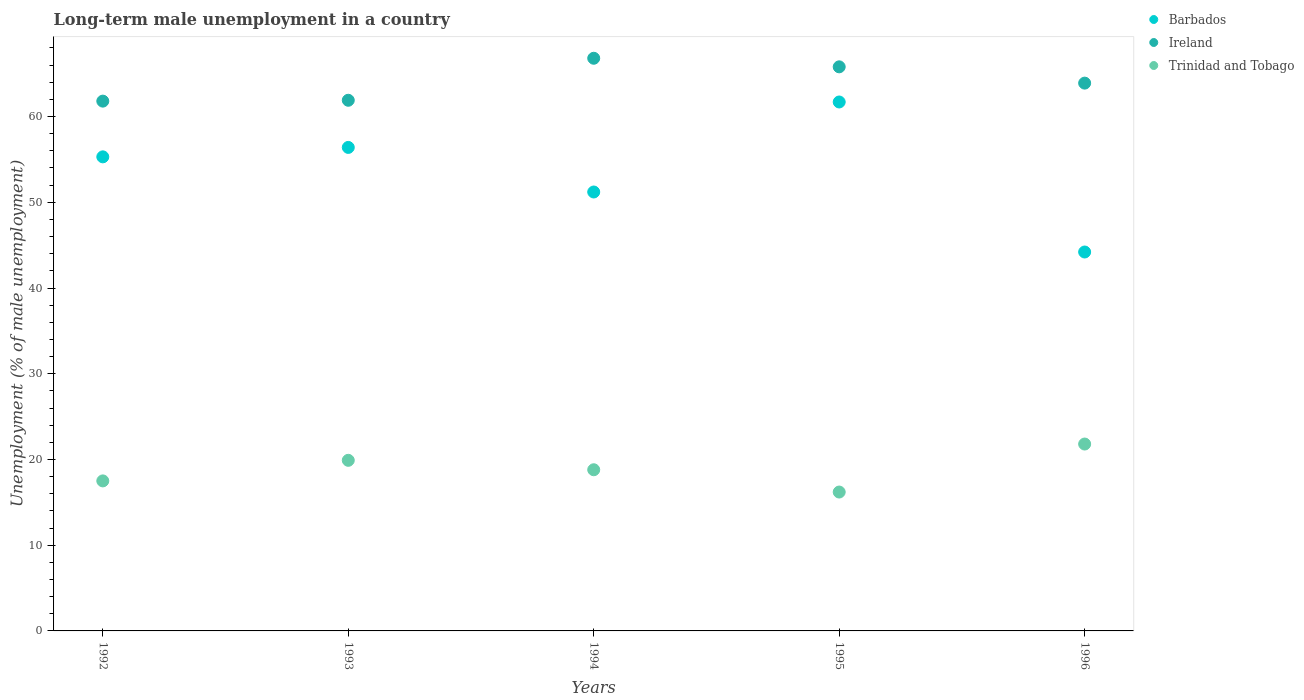Is the number of dotlines equal to the number of legend labels?
Provide a short and direct response. Yes. What is the percentage of long-term unemployed male population in Trinidad and Tobago in 1993?
Your answer should be very brief. 19.9. Across all years, what is the maximum percentage of long-term unemployed male population in Trinidad and Tobago?
Your response must be concise. 21.8. Across all years, what is the minimum percentage of long-term unemployed male population in Trinidad and Tobago?
Make the answer very short. 16.2. What is the total percentage of long-term unemployed male population in Ireland in the graph?
Your response must be concise. 320.2. What is the difference between the percentage of long-term unemployed male population in Barbados in 1993 and that in 1994?
Provide a short and direct response. 5.2. What is the difference between the percentage of long-term unemployed male population in Ireland in 1992 and the percentage of long-term unemployed male population in Trinidad and Tobago in 1994?
Give a very brief answer. 43. What is the average percentage of long-term unemployed male population in Trinidad and Tobago per year?
Your answer should be compact. 18.84. In the year 1992, what is the difference between the percentage of long-term unemployed male population in Trinidad and Tobago and percentage of long-term unemployed male population in Barbados?
Your answer should be compact. -37.8. In how many years, is the percentage of long-term unemployed male population in Barbados greater than 30 %?
Make the answer very short. 5. What is the ratio of the percentage of long-term unemployed male population in Trinidad and Tobago in 1993 to that in 1995?
Provide a succinct answer. 1.23. Is the percentage of long-term unemployed male population in Trinidad and Tobago in 1995 less than that in 1996?
Provide a short and direct response. Yes. What is the difference between the highest and the second highest percentage of long-term unemployed male population in Ireland?
Your response must be concise. 1. What is the difference between the highest and the lowest percentage of long-term unemployed male population in Trinidad and Tobago?
Provide a short and direct response. 5.6. In how many years, is the percentage of long-term unemployed male population in Barbados greater than the average percentage of long-term unemployed male population in Barbados taken over all years?
Offer a very short reply. 3. Is the sum of the percentage of long-term unemployed male population in Barbados in 1992 and 1995 greater than the maximum percentage of long-term unemployed male population in Ireland across all years?
Offer a very short reply. Yes. Is it the case that in every year, the sum of the percentage of long-term unemployed male population in Barbados and percentage of long-term unemployed male population in Trinidad and Tobago  is greater than the percentage of long-term unemployed male population in Ireland?
Offer a terse response. Yes. Are the values on the major ticks of Y-axis written in scientific E-notation?
Provide a short and direct response. No. Does the graph contain grids?
Ensure brevity in your answer.  No. Where does the legend appear in the graph?
Keep it short and to the point. Top right. How many legend labels are there?
Provide a short and direct response. 3. How are the legend labels stacked?
Your answer should be very brief. Vertical. What is the title of the graph?
Your response must be concise. Long-term male unemployment in a country. Does "St. Vincent and the Grenadines" appear as one of the legend labels in the graph?
Provide a short and direct response. No. What is the label or title of the Y-axis?
Provide a succinct answer. Unemployment (% of male unemployment). What is the Unemployment (% of male unemployment) of Barbados in 1992?
Your response must be concise. 55.3. What is the Unemployment (% of male unemployment) in Ireland in 1992?
Make the answer very short. 61.8. What is the Unemployment (% of male unemployment) of Trinidad and Tobago in 1992?
Make the answer very short. 17.5. What is the Unemployment (% of male unemployment) in Barbados in 1993?
Your answer should be very brief. 56.4. What is the Unemployment (% of male unemployment) of Ireland in 1993?
Offer a very short reply. 61.9. What is the Unemployment (% of male unemployment) of Trinidad and Tobago in 1993?
Make the answer very short. 19.9. What is the Unemployment (% of male unemployment) of Barbados in 1994?
Ensure brevity in your answer.  51.2. What is the Unemployment (% of male unemployment) of Ireland in 1994?
Ensure brevity in your answer.  66.8. What is the Unemployment (% of male unemployment) in Trinidad and Tobago in 1994?
Your answer should be compact. 18.8. What is the Unemployment (% of male unemployment) in Barbados in 1995?
Make the answer very short. 61.7. What is the Unemployment (% of male unemployment) of Ireland in 1995?
Provide a succinct answer. 65.8. What is the Unemployment (% of male unemployment) of Trinidad and Tobago in 1995?
Provide a short and direct response. 16.2. What is the Unemployment (% of male unemployment) in Barbados in 1996?
Your answer should be very brief. 44.2. What is the Unemployment (% of male unemployment) in Ireland in 1996?
Make the answer very short. 63.9. What is the Unemployment (% of male unemployment) of Trinidad and Tobago in 1996?
Provide a short and direct response. 21.8. Across all years, what is the maximum Unemployment (% of male unemployment) in Barbados?
Offer a terse response. 61.7. Across all years, what is the maximum Unemployment (% of male unemployment) of Ireland?
Your response must be concise. 66.8. Across all years, what is the maximum Unemployment (% of male unemployment) in Trinidad and Tobago?
Provide a short and direct response. 21.8. Across all years, what is the minimum Unemployment (% of male unemployment) in Barbados?
Provide a short and direct response. 44.2. Across all years, what is the minimum Unemployment (% of male unemployment) of Ireland?
Your response must be concise. 61.8. Across all years, what is the minimum Unemployment (% of male unemployment) of Trinidad and Tobago?
Ensure brevity in your answer.  16.2. What is the total Unemployment (% of male unemployment) of Barbados in the graph?
Your answer should be compact. 268.8. What is the total Unemployment (% of male unemployment) in Ireland in the graph?
Ensure brevity in your answer.  320.2. What is the total Unemployment (% of male unemployment) in Trinidad and Tobago in the graph?
Provide a short and direct response. 94.2. What is the difference between the Unemployment (% of male unemployment) of Barbados in 1992 and that in 1993?
Ensure brevity in your answer.  -1.1. What is the difference between the Unemployment (% of male unemployment) in Ireland in 1992 and that in 1993?
Your answer should be compact. -0.1. What is the difference between the Unemployment (% of male unemployment) of Trinidad and Tobago in 1992 and that in 1993?
Your response must be concise. -2.4. What is the difference between the Unemployment (% of male unemployment) in Barbados in 1992 and that in 1995?
Provide a short and direct response. -6.4. What is the difference between the Unemployment (% of male unemployment) of Ireland in 1992 and that in 1995?
Offer a terse response. -4. What is the difference between the Unemployment (% of male unemployment) in Ireland in 1992 and that in 1996?
Ensure brevity in your answer.  -2.1. What is the difference between the Unemployment (% of male unemployment) in Trinidad and Tobago in 1992 and that in 1996?
Your response must be concise. -4.3. What is the difference between the Unemployment (% of male unemployment) in Ireland in 1993 and that in 1994?
Your response must be concise. -4.9. What is the difference between the Unemployment (% of male unemployment) in Trinidad and Tobago in 1993 and that in 1994?
Offer a very short reply. 1.1. What is the difference between the Unemployment (% of male unemployment) in Barbados in 1993 and that in 1995?
Offer a very short reply. -5.3. What is the difference between the Unemployment (% of male unemployment) of Trinidad and Tobago in 1993 and that in 1995?
Ensure brevity in your answer.  3.7. What is the difference between the Unemployment (% of male unemployment) in Trinidad and Tobago in 1993 and that in 1996?
Make the answer very short. -1.9. What is the difference between the Unemployment (% of male unemployment) of Barbados in 1994 and that in 1995?
Provide a short and direct response. -10.5. What is the difference between the Unemployment (% of male unemployment) of Ireland in 1994 and that in 1995?
Ensure brevity in your answer.  1. What is the difference between the Unemployment (% of male unemployment) in Trinidad and Tobago in 1994 and that in 1995?
Your response must be concise. 2.6. What is the difference between the Unemployment (% of male unemployment) of Barbados in 1994 and that in 1996?
Provide a succinct answer. 7. What is the difference between the Unemployment (% of male unemployment) in Barbados in 1995 and that in 1996?
Offer a terse response. 17.5. What is the difference between the Unemployment (% of male unemployment) of Trinidad and Tobago in 1995 and that in 1996?
Provide a succinct answer. -5.6. What is the difference between the Unemployment (% of male unemployment) in Barbados in 1992 and the Unemployment (% of male unemployment) in Trinidad and Tobago in 1993?
Offer a very short reply. 35.4. What is the difference between the Unemployment (% of male unemployment) of Ireland in 1992 and the Unemployment (% of male unemployment) of Trinidad and Tobago in 1993?
Ensure brevity in your answer.  41.9. What is the difference between the Unemployment (% of male unemployment) of Barbados in 1992 and the Unemployment (% of male unemployment) of Trinidad and Tobago in 1994?
Your answer should be very brief. 36.5. What is the difference between the Unemployment (% of male unemployment) of Ireland in 1992 and the Unemployment (% of male unemployment) of Trinidad and Tobago in 1994?
Offer a very short reply. 43. What is the difference between the Unemployment (% of male unemployment) in Barbados in 1992 and the Unemployment (% of male unemployment) in Ireland in 1995?
Provide a succinct answer. -10.5. What is the difference between the Unemployment (% of male unemployment) in Barbados in 1992 and the Unemployment (% of male unemployment) in Trinidad and Tobago in 1995?
Keep it short and to the point. 39.1. What is the difference between the Unemployment (% of male unemployment) of Ireland in 1992 and the Unemployment (% of male unemployment) of Trinidad and Tobago in 1995?
Provide a short and direct response. 45.6. What is the difference between the Unemployment (% of male unemployment) of Barbados in 1992 and the Unemployment (% of male unemployment) of Trinidad and Tobago in 1996?
Give a very brief answer. 33.5. What is the difference between the Unemployment (% of male unemployment) in Barbados in 1993 and the Unemployment (% of male unemployment) in Trinidad and Tobago in 1994?
Your response must be concise. 37.6. What is the difference between the Unemployment (% of male unemployment) of Ireland in 1993 and the Unemployment (% of male unemployment) of Trinidad and Tobago in 1994?
Offer a terse response. 43.1. What is the difference between the Unemployment (% of male unemployment) of Barbados in 1993 and the Unemployment (% of male unemployment) of Trinidad and Tobago in 1995?
Make the answer very short. 40.2. What is the difference between the Unemployment (% of male unemployment) in Ireland in 1993 and the Unemployment (% of male unemployment) in Trinidad and Tobago in 1995?
Give a very brief answer. 45.7. What is the difference between the Unemployment (% of male unemployment) of Barbados in 1993 and the Unemployment (% of male unemployment) of Trinidad and Tobago in 1996?
Provide a short and direct response. 34.6. What is the difference between the Unemployment (% of male unemployment) of Ireland in 1993 and the Unemployment (% of male unemployment) of Trinidad and Tobago in 1996?
Offer a terse response. 40.1. What is the difference between the Unemployment (% of male unemployment) in Barbados in 1994 and the Unemployment (% of male unemployment) in Ireland in 1995?
Your answer should be compact. -14.6. What is the difference between the Unemployment (% of male unemployment) of Barbados in 1994 and the Unemployment (% of male unemployment) of Trinidad and Tobago in 1995?
Give a very brief answer. 35. What is the difference between the Unemployment (% of male unemployment) in Ireland in 1994 and the Unemployment (% of male unemployment) in Trinidad and Tobago in 1995?
Ensure brevity in your answer.  50.6. What is the difference between the Unemployment (% of male unemployment) of Barbados in 1994 and the Unemployment (% of male unemployment) of Trinidad and Tobago in 1996?
Keep it short and to the point. 29.4. What is the difference between the Unemployment (% of male unemployment) of Ireland in 1994 and the Unemployment (% of male unemployment) of Trinidad and Tobago in 1996?
Your answer should be compact. 45. What is the difference between the Unemployment (% of male unemployment) in Barbados in 1995 and the Unemployment (% of male unemployment) in Ireland in 1996?
Offer a terse response. -2.2. What is the difference between the Unemployment (% of male unemployment) in Barbados in 1995 and the Unemployment (% of male unemployment) in Trinidad and Tobago in 1996?
Offer a very short reply. 39.9. What is the difference between the Unemployment (% of male unemployment) of Ireland in 1995 and the Unemployment (% of male unemployment) of Trinidad and Tobago in 1996?
Ensure brevity in your answer.  44. What is the average Unemployment (% of male unemployment) in Barbados per year?
Ensure brevity in your answer.  53.76. What is the average Unemployment (% of male unemployment) of Ireland per year?
Make the answer very short. 64.04. What is the average Unemployment (% of male unemployment) in Trinidad and Tobago per year?
Provide a succinct answer. 18.84. In the year 1992, what is the difference between the Unemployment (% of male unemployment) of Barbados and Unemployment (% of male unemployment) of Ireland?
Offer a very short reply. -6.5. In the year 1992, what is the difference between the Unemployment (% of male unemployment) in Barbados and Unemployment (% of male unemployment) in Trinidad and Tobago?
Make the answer very short. 37.8. In the year 1992, what is the difference between the Unemployment (% of male unemployment) in Ireland and Unemployment (% of male unemployment) in Trinidad and Tobago?
Your response must be concise. 44.3. In the year 1993, what is the difference between the Unemployment (% of male unemployment) of Barbados and Unemployment (% of male unemployment) of Ireland?
Provide a short and direct response. -5.5. In the year 1993, what is the difference between the Unemployment (% of male unemployment) of Barbados and Unemployment (% of male unemployment) of Trinidad and Tobago?
Your answer should be compact. 36.5. In the year 1993, what is the difference between the Unemployment (% of male unemployment) of Ireland and Unemployment (% of male unemployment) of Trinidad and Tobago?
Provide a succinct answer. 42. In the year 1994, what is the difference between the Unemployment (% of male unemployment) of Barbados and Unemployment (% of male unemployment) of Ireland?
Your response must be concise. -15.6. In the year 1994, what is the difference between the Unemployment (% of male unemployment) of Barbados and Unemployment (% of male unemployment) of Trinidad and Tobago?
Provide a short and direct response. 32.4. In the year 1994, what is the difference between the Unemployment (% of male unemployment) in Ireland and Unemployment (% of male unemployment) in Trinidad and Tobago?
Your answer should be very brief. 48. In the year 1995, what is the difference between the Unemployment (% of male unemployment) in Barbados and Unemployment (% of male unemployment) in Trinidad and Tobago?
Provide a succinct answer. 45.5. In the year 1995, what is the difference between the Unemployment (% of male unemployment) of Ireland and Unemployment (% of male unemployment) of Trinidad and Tobago?
Give a very brief answer. 49.6. In the year 1996, what is the difference between the Unemployment (% of male unemployment) in Barbados and Unemployment (% of male unemployment) in Ireland?
Ensure brevity in your answer.  -19.7. In the year 1996, what is the difference between the Unemployment (% of male unemployment) of Barbados and Unemployment (% of male unemployment) of Trinidad and Tobago?
Provide a short and direct response. 22.4. In the year 1996, what is the difference between the Unemployment (% of male unemployment) of Ireland and Unemployment (% of male unemployment) of Trinidad and Tobago?
Your answer should be very brief. 42.1. What is the ratio of the Unemployment (% of male unemployment) in Barbados in 1992 to that in 1993?
Ensure brevity in your answer.  0.98. What is the ratio of the Unemployment (% of male unemployment) in Ireland in 1992 to that in 1993?
Give a very brief answer. 1. What is the ratio of the Unemployment (% of male unemployment) of Trinidad and Tobago in 1992 to that in 1993?
Keep it short and to the point. 0.88. What is the ratio of the Unemployment (% of male unemployment) of Barbados in 1992 to that in 1994?
Provide a succinct answer. 1.08. What is the ratio of the Unemployment (% of male unemployment) of Ireland in 1992 to that in 1994?
Your response must be concise. 0.93. What is the ratio of the Unemployment (% of male unemployment) of Trinidad and Tobago in 1992 to that in 1994?
Your answer should be compact. 0.93. What is the ratio of the Unemployment (% of male unemployment) in Barbados in 1992 to that in 1995?
Provide a succinct answer. 0.9. What is the ratio of the Unemployment (% of male unemployment) of Ireland in 1992 to that in 1995?
Your response must be concise. 0.94. What is the ratio of the Unemployment (% of male unemployment) in Trinidad and Tobago in 1992 to that in 1995?
Make the answer very short. 1.08. What is the ratio of the Unemployment (% of male unemployment) in Barbados in 1992 to that in 1996?
Your answer should be very brief. 1.25. What is the ratio of the Unemployment (% of male unemployment) in Ireland in 1992 to that in 1996?
Offer a terse response. 0.97. What is the ratio of the Unemployment (% of male unemployment) of Trinidad and Tobago in 1992 to that in 1996?
Your answer should be very brief. 0.8. What is the ratio of the Unemployment (% of male unemployment) of Barbados in 1993 to that in 1994?
Your answer should be compact. 1.1. What is the ratio of the Unemployment (% of male unemployment) in Ireland in 1993 to that in 1994?
Provide a short and direct response. 0.93. What is the ratio of the Unemployment (% of male unemployment) of Trinidad and Tobago in 1993 to that in 1994?
Your answer should be very brief. 1.06. What is the ratio of the Unemployment (% of male unemployment) in Barbados in 1993 to that in 1995?
Offer a terse response. 0.91. What is the ratio of the Unemployment (% of male unemployment) in Ireland in 1993 to that in 1995?
Provide a short and direct response. 0.94. What is the ratio of the Unemployment (% of male unemployment) in Trinidad and Tobago in 1993 to that in 1995?
Keep it short and to the point. 1.23. What is the ratio of the Unemployment (% of male unemployment) in Barbados in 1993 to that in 1996?
Offer a very short reply. 1.28. What is the ratio of the Unemployment (% of male unemployment) of Ireland in 1993 to that in 1996?
Offer a very short reply. 0.97. What is the ratio of the Unemployment (% of male unemployment) of Trinidad and Tobago in 1993 to that in 1996?
Keep it short and to the point. 0.91. What is the ratio of the Unemployment (% of male unemployment) of Barbados in 1994 to that in 1995?
Give a very brief answer. 0.83. What is the ratio of the Unemployment (% of male unemployment) in Ireland in 1994 to that in 1995?
Offer a terse response. 1.02. What is the ratio of the Unemployment (% of male unemployment) of Trinidad and Tobago in 1994 to that in 1995?
Keep it short and to the point. 1.16. What is the ratio of the Unemployment (% of male unemployment) of Barbados in 1994 to that in 1996?
Your answer should be very brief. 1.16. What is the ratio of the Unemployment (% of male unemployment) in Ireland in 1994 to that in 1996?
Provide a short and direct response. 1.05. What is the ratio of the Unemployment (% of male unemployment) of Trinidad and Tobago in 1994 to that in 1996?
Provide a short and direct response. 0.86. What is the ratio of the Unemployment (% of male unemployment) of Barbados in 1995 to that in 1996?
Keep it short and to the point. 1.4. What is the ratio of the Unemployment (% of male unemployment) in Ireland in 1995 to that in 1996?
Provide a short and direct response. 1.03. What is the ratio of the Unemployment (% of male unemployment) of Trinidad and Tobago in 1995 to that in 1996?
Provide a succinct answer. 0.74. What is the difference between the highest and the second highest Unemployment (% of male unemployment) in Ireland?
Give a very brief answer. 1. What is the difference between the highest and the lowest Unemployment (% of male unemployment) of Barbados?
Provide a succinct answer. 17.5. What is the difference between the highest and the lowest Unemployment (% of male unemployment) in Ireland?
Keep it short and to the point. 5. 